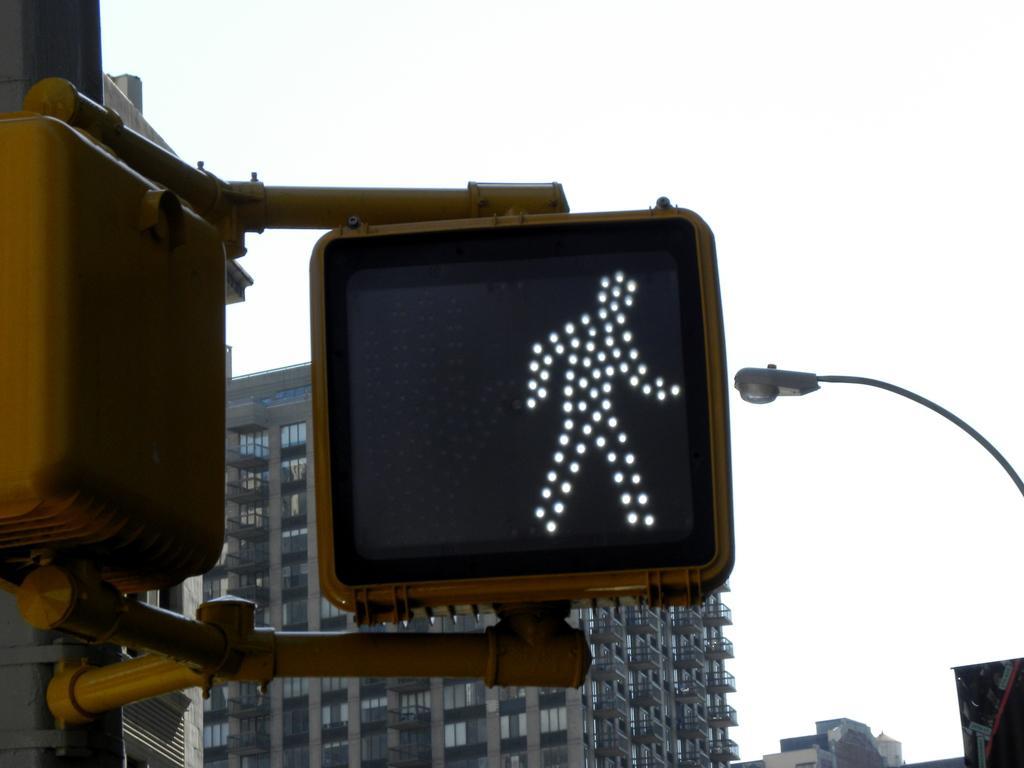Can you describe this image briefly? In this picture we can see a traffic signal and in the background we can see buildings. 